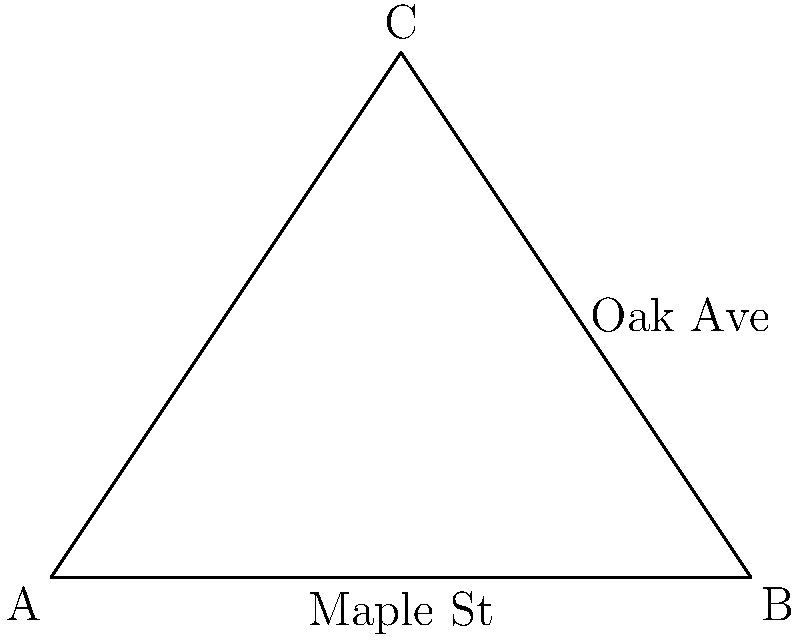In our neighborhood, Maple Street intersects with Oak Avenue. From Willie's house at point A, Maple Street runs east for 4 blocks to point B, where it meets Oak Avenue. Oak Avenue then continues for 3 blocks to point C. If the distance between Willie's house (A) and point C is 5 blocks, what is the angle between Maple Street and Oak Avenue at their intersection (point B)? Let's approach this step-by-step:

1) We can treat this as a triangle problem, where:
   - AB is Maple Street (4 blocks)
   - BC is Oak Avenue (3 blocks)
   - AC is the straight line from Willie's house to point C (5 blocks)

2) We now have a triangle with all sides known:
   AB = 4, BC = 3, AC = 5

3) We can use the law of cosines to find the angle at B:
   $\cos \angle B = \frac{AB^2 + BC^2 - AC^2}{2(AB)(BC)}$

4) Substituting our values:
   $\cos \angle B = \frac{4^2 + 3^2 - 5^2}{2(4)(3)}$

5) Simplifying:
   $\cos \angle B = \frac{16 + 9 - 25}{24} = \frac{0}{24} = 0$

6) Therefore:
   $\angle B = \arccos(0) = 90°$

Thus, Maple Street and Oak Avenue intersect at a right angle.
Answer: 90° 